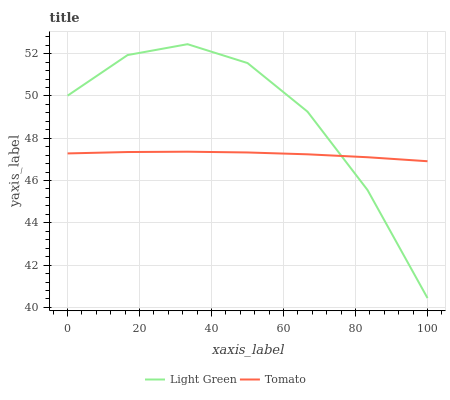Does Tomato have the minimum area under the curve?
Answer yes or no. Yes. Does Light Green have the maximum area under the curve?
Answer yes or no. Yes. Does Light Green have the minimum area under the curve?
Answer yes or no. No. Is Tomato the smoothest?
Answer yes or no. Yes. Is Light Green the roughest?
Answer yes or no. Yes. Is Light Green the smoothest?
Answer yes or no. No. Does Light Green have the lowest value?
Answer yes or no. Yes. Does Light Green have the highest value?
Answer yes or no. Yes. Does Tomato intersect Light Green?
Answer yes or no. Yes. Is Tomato less than Light Green?
Answer yes or no. No. Is Tomato greater than Light Green?
Answer yes or no. No. 